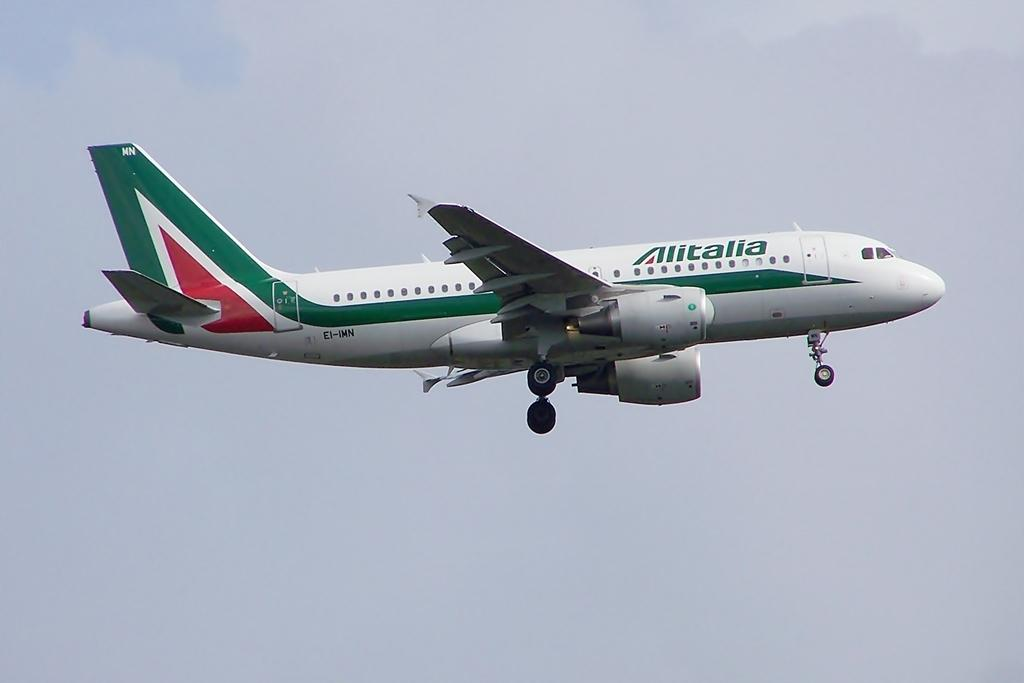<image>
Present a compact description of the photo's key features. A green and white airplane with the name Alitalia and the call letters EI-IMN. 